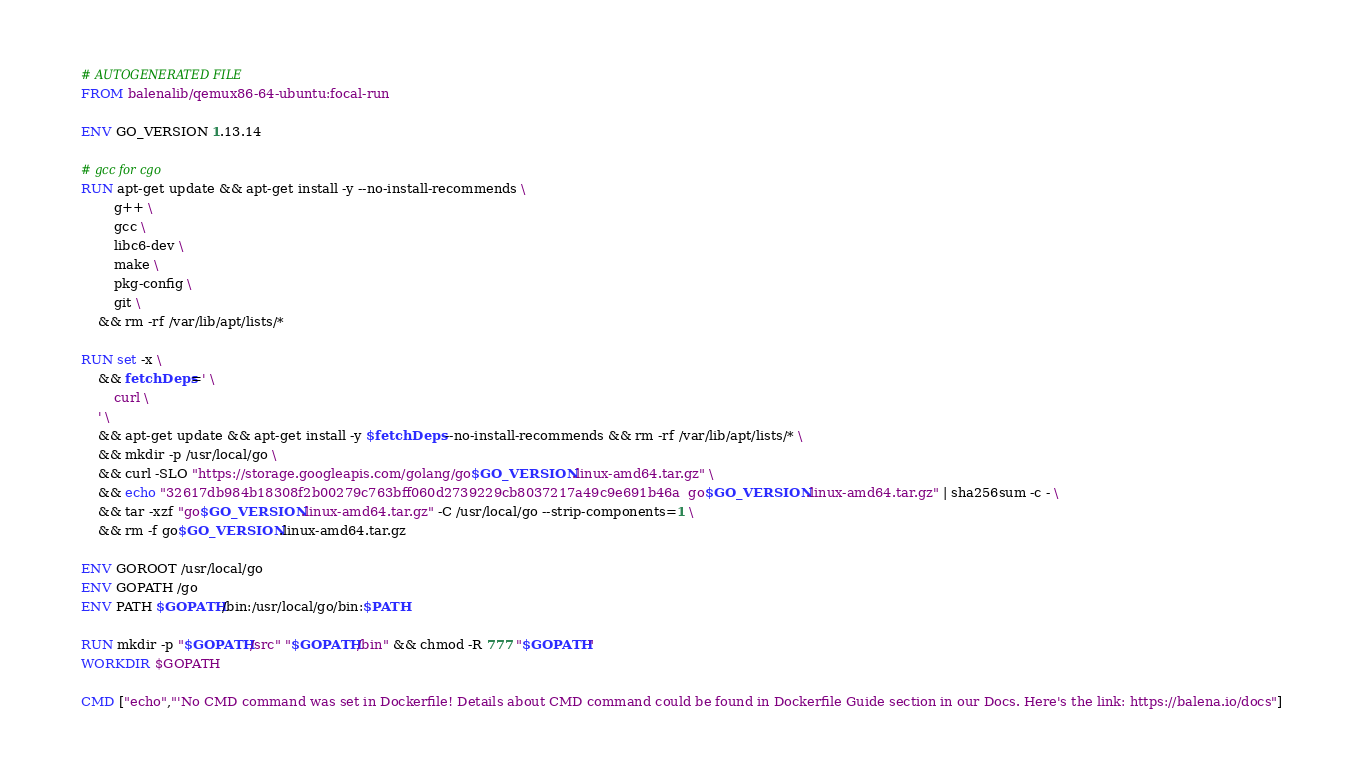Convert code to text. <code><loc_0><loc_0><loc_500><loc_500><_Dockerfile_># AUTOGENERATED FILE
FROM balenalib/qemux86-64-ubuntu:focal-run

ENV GO_VERSION 1.13.14

# gcc for cgo
RUN apt-get update && apt-get install -y --no-install-recommends \
		g++ \
		gcc \
		libc6-dev \
		make \
		pkg-config \
		git \
	&& rm -rf /var/lib/apt/lists/*

RUN set -x \
	&& fetchDeps=' \
		curl \
	' \
	&& apt-get update && apt-get install -y $fetchDeps --no-install-recommends && rm -rf /var/lib/apt/lists/* \
	&& mkdir -p /usr/local/go \
	&& curl -SLO "https://storage.googleapis.com/golang/go$GO_VERSION.linux-amd64.tar.gz" \
	&& echo "32617db984b18308f2b00279c763bff060d2739229cb8037217a49c9e691b46a  go$GO_VERSION.linux-amd64.tar.gz" | sha256sum -c - \
	&& tar -xzf "go$GO_VERSION.linux-amd64.tar.gz" -C /usr/local/go --strip-components=1 \
	&& rm -f go$GO_VERSION.linux-amd64.tar.gz

ENV GOROOT /usr/local/go
ENV GOPATH /go
ENV PATH $GOPATH/bin:/usr/local/go/bin:$PATH

RUN mkdir -p "$GOPATH/src" "$GOPATH/bin" && chmod -R 777 "$GOPATH"
WORKDIR $GOPATH

CMD ["echo","'No CMD command was set in Dockerfile! Details about CMD command could be found in Dockerfile Guide section in our Docs. Here's the link: https://balena.io/docs"]
</code> 